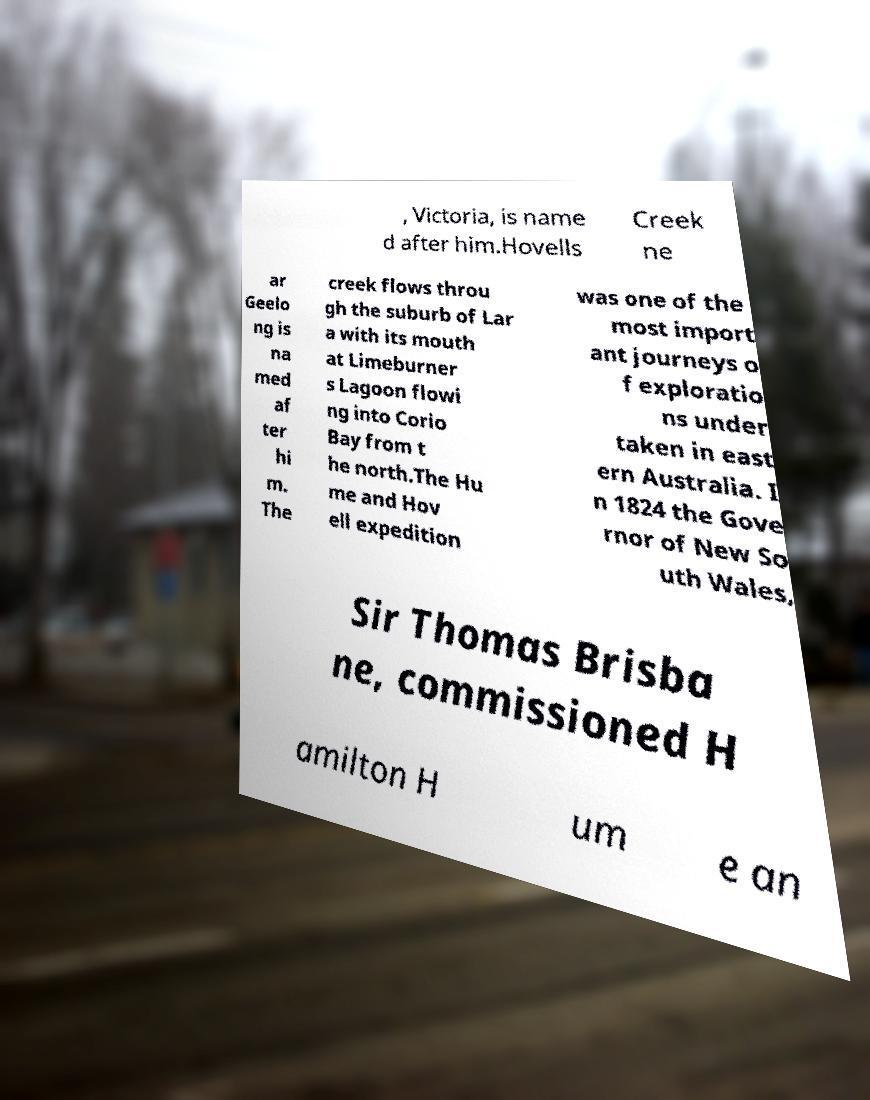Could you assist in decoding the text presented in this image and type it out clearly? , Victoria, is name d after him.Hovells Creek ne ar Geelo ng is na med af ter hi m. The creek flows throu gh the suburb of Lar a with its mouth at Limeburner s Lagoon flowi ng into Corio Bay from t he north.The Hu me and Hov ell expedition was one of the most import ant journeys o f exploratio ns under taken in east ern Australia. I n 1824 the Gove rnor of New So uth Wales, Sir Thomas Brisba ne, commissioned H amilton H um e an 